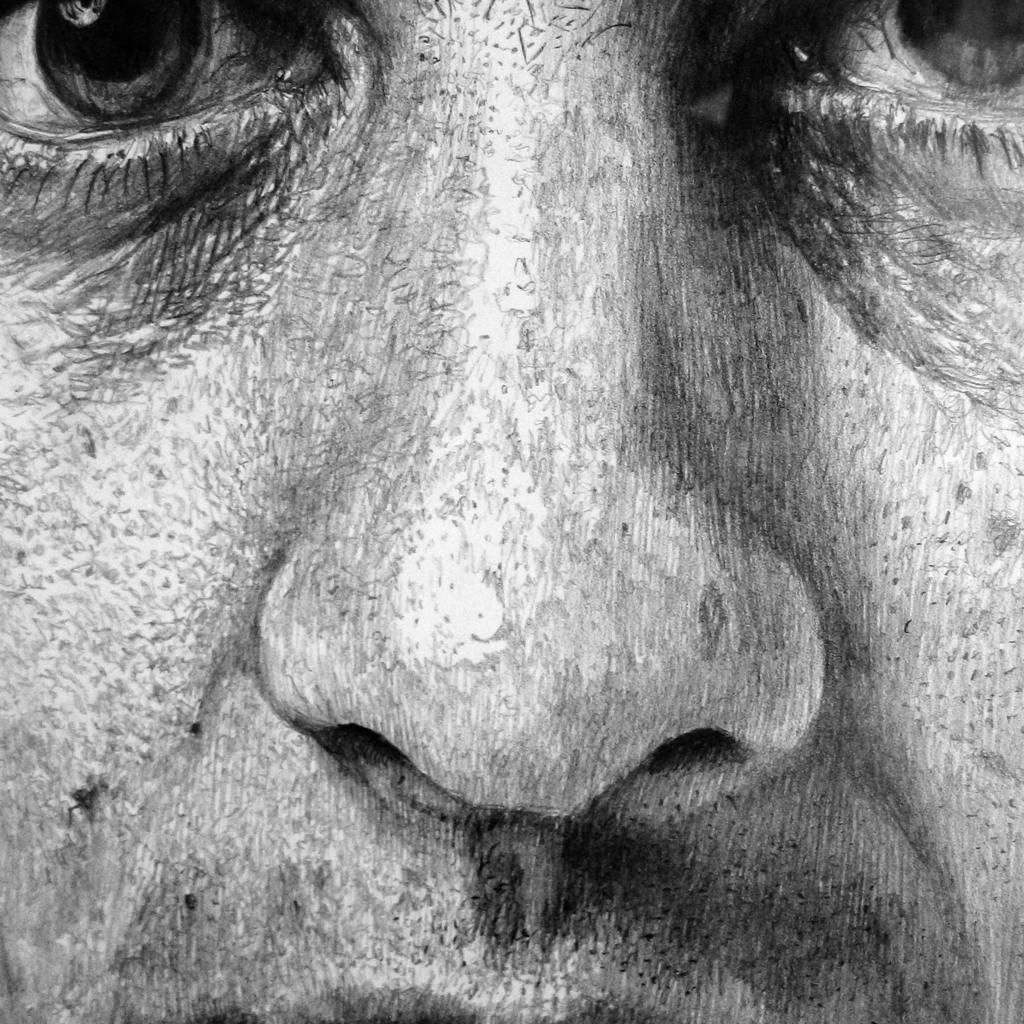What is the main subject of the image? There is a face of a person in the image. What number is associated with the feeling of happiness in the image? There is no number or reference to feelings in the image; it only features the face of a person. 